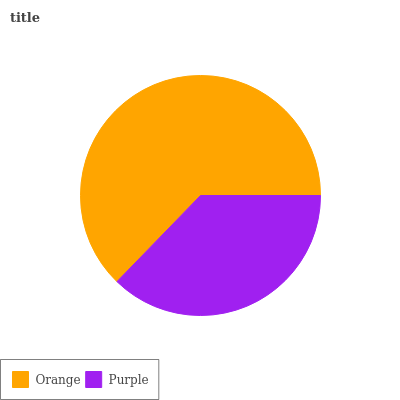Is Purple the minimum?
Answer yes or no. Yes. Is Orange the maximum?
Answer yes or no. Yes. Is Purple the maximum?
Answer yes or no. No. Is Orange greater than Purple?
Answer yes or no. Yes. Is Purple less than Orange?
Answer yes or no. Yes. Is Purple greater than Orange?
Answer yes or no. No. Is Orange less than Purple?
Answer yes or no. No. Is Orange the high median?
Answer yes or no. Yes. Is Purple the low median?
Answer yes or no. Yes. Is Purple the high median?
Answer yes or no. No. Is Orange the low median?
Answer yes or no. No. 